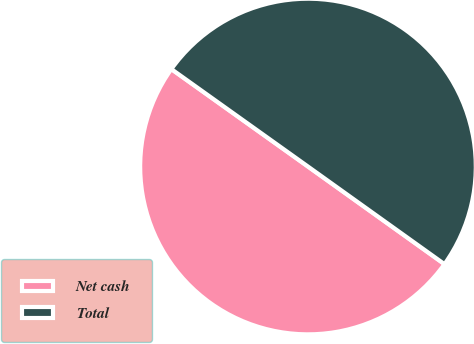Convert chart to OTSL. <chart><loc_0><loc_0><loc_500><loc_500><pie_chart><fcel>Net cash<fcel>Total<nl><fcel>49.98%<fcel>50.02%<nl></chart> 